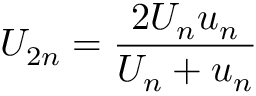Convert formula to latex. <formula><loc_0><loc_0><loc_500><loc_500>U _ { 2 n } = { \frac { 2 U _ { n } u _ { n } } { U _ { n } + u _ { n } } }</formula> 